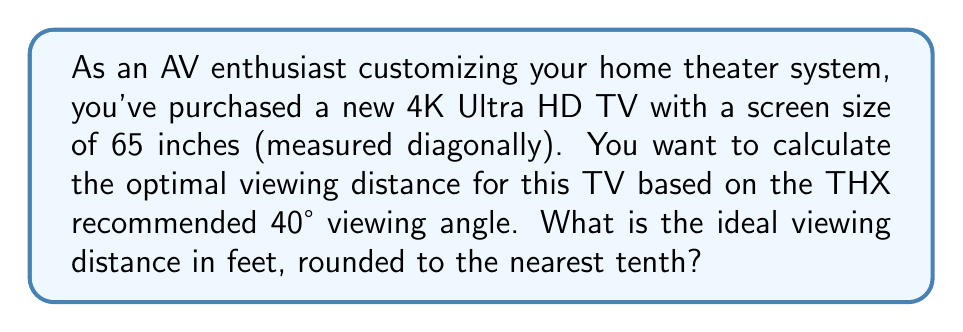Can you solve this math problem? To solve this problem, we'll follow these steps:

1. Calculate the width of the screen:
   The aspect ratio of a 4K TV is 16:9. We can use the Pythagorean theorem to find the width.

   Let $w$ be the width and $h$ be the height:
   $$w^2 + (\frac{9w}{16})^2 = 65^2$$

   Simplifying:
   $$w^2 + 0.316406w^2 = 4225$$
   $$1.316406w^2 = 4225$$
   $$w^2 = 3209.54$$
   $$w = 56.65 \text{ inches}$$

2. Calculate the optimal viewing distance:
   For a 40° viewing angle, we can use the tangent function:
   
   $$\tan(20°) = \frac{\text{opposite}}{\text{adjacent}} = \frac{\text{half screen width}}{\text{viewing distance}}$$

   Rearranging:
   $$\text{viewing distance} = \frac{\text{half screen width}}{\tan(20°)}$$

   $$\text{viewing distance} = \frac{56.65/2}{\tan(20°)} = \frac{28.325}{0.3640} = 77.82 \text{ inches}$$

3. Convert to feet:
   $$77.82 \text{ inches} \div 12 = 6.485 \text{ feet}$$

4. Round to the nearest tenth:
   $$6.5 \text{ feet}$$
Answer: The optimal viewing distance is 6.5 feet. 